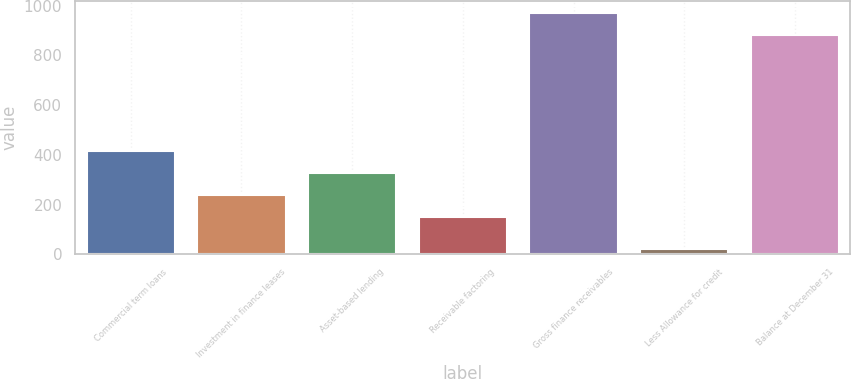<chart> <loc_0><loc_0><loc_500><loc_500><bar_chart><fcel>Commercial term loans<fcel>Investment in finance leases<fcel>Asset-based lending<fcel>Receivable factoring<fcel>Gross finance receivables<fcel>Less Allowance for credit<fcel>Balance at December 31<nl><fcel>415.6<fcel>239.2<fcel>327.4<fcel>151<fcel>970.2<fcel>20<fcel>882<nl></chart> 